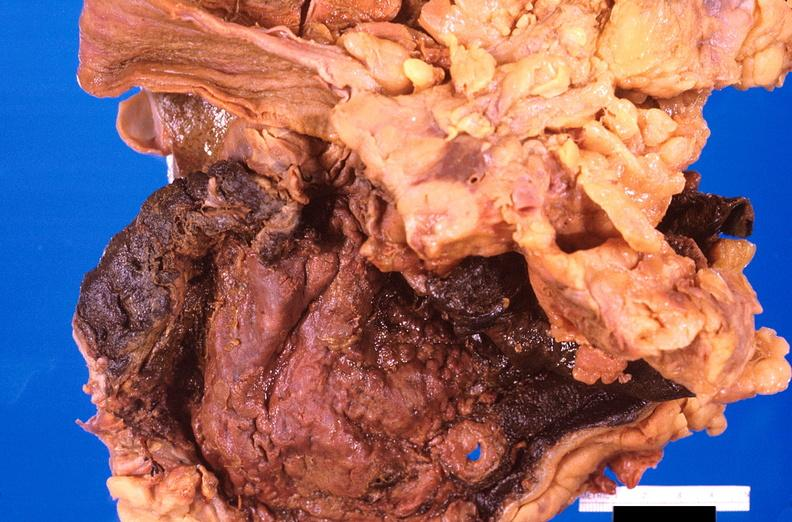does this typical thecoma with yellow foci show stomach, necrotizing esophagitis and gastritis, sulfuric acid ingested as suicide attempt?
Answer the question using a single word or phrase. No 